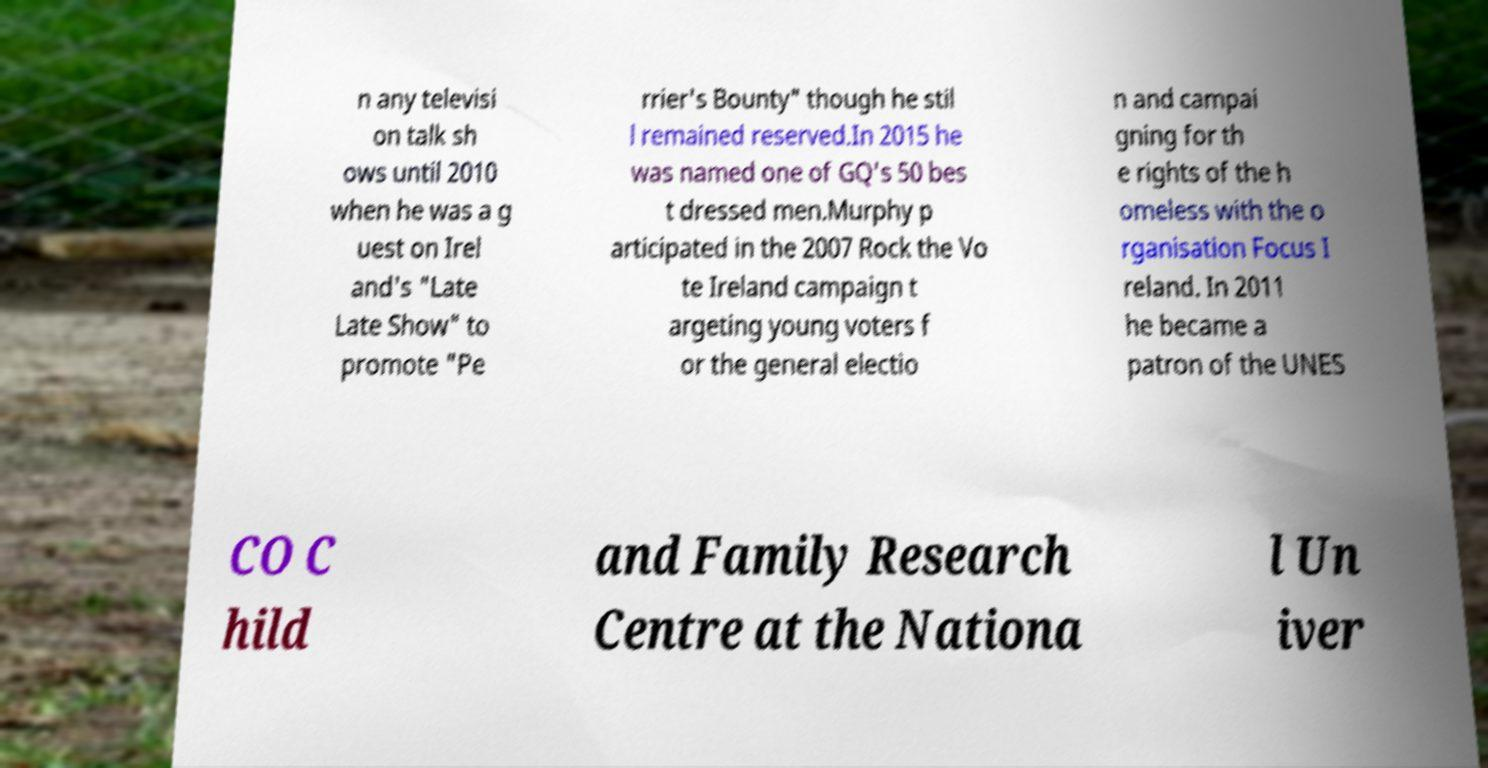Can you accurately transcribe the text from the provided image for me? n any televisi on talk sh ows until 2010 when he was a g uest on Irel and's "Late Late Show" to promote "Pe rrier's Bounty" though he stil l remained reserved.In 2015 he was named one of GQ's 50 bes t dressed men.Murphy p articipated in the 2007 Rock the Vo te Ireland campaign t argeting young voters f or the general electio n and campai gning for th e rights of the h omeless with the o rganisation Focus I reland. In 2011 he became a patron of the UNES CO C hild and Family Research Centre at the Nationa l Un iver 